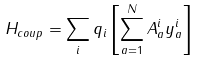<formula> <loc_0><loc_0><loc_500><loc_500>H _ { c o u p } = \sum _ { i } q _ { i } \left [ \sum _ { a = 1 } ^ { N } A ^ { i } _ { a } y _ { a } ^ { i } \right ]</formula> 